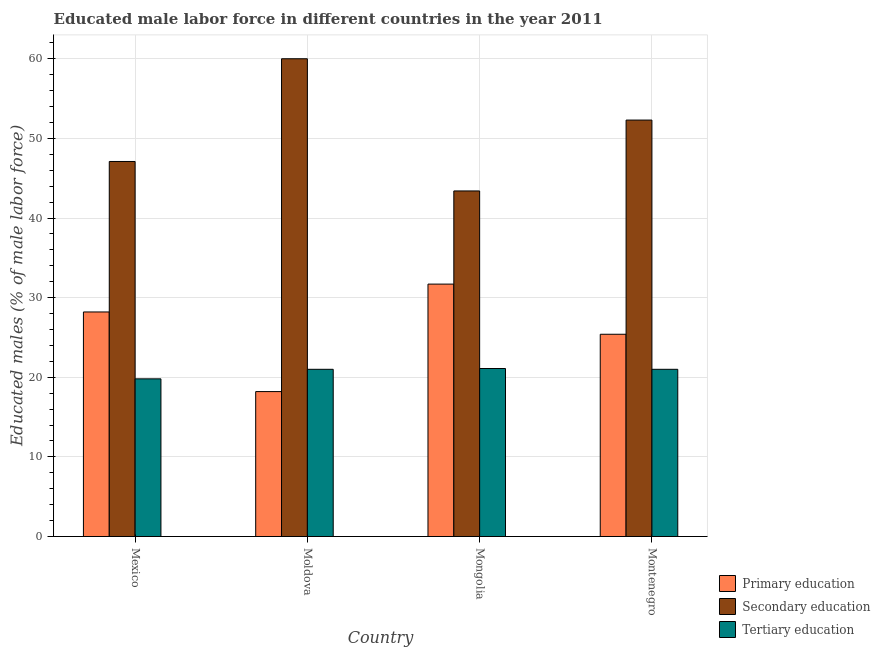How many different coloured bars are there?
Provide a succinct answer. 3. What is the label of the 4th group of bars from the left?
Keep it short and to the point. Montenegro. What is the percentage of male labor force who received primary education in Montenegro?
Keep it short and to the point. 25.4. Across all countries, what is the maximum percentage of male labor force who received secondary education?
Offer a very short reply. 60. Across all countries, what is the minimum percentage of male labor force who received tertiary education?
Keep it short and to the point. 19.8. In which country was the percentage of male labor force who received tertiary education maximum?
Provide a succinct answer. Mongolia. In which country was the percentage of male labor force who received primary education minimum?
Your answer should be very brief. Moldova. What is the total percentage of male labor force who received tertiary education in the graph?
Provide a short and direct response. 82.9. What is the difference between the percentage of male labor force who received tertiary education in Mexico and that in Mongolia?
Make the answer very short. -1.3. What is the difference between the percentage of male labor force who received tertiary education in Mexico and the percentage of male labor force who received secondary education in Mongolia?
Ensure brevity in your answer.  -23.6. What is the average percentage of male labor force who received primary education per country?
Provide a succinct answer. 25.88. What is the difference between the percentage of male labor force who received primary education and percentage of male labor force who received tertiary education in Montenegro?
Ensure brevity in your answer.  4.4. In how many countries, is the percentage of male labor force who received tertiary education greater than 52 %?
Your answer should be compact. 0. What is the ratio of the percentage of male labor force who received secondary education in Mexico to that in Mongolia?
Provide a succinct answer. 1.09. Is the percentage of male labor force who received secondary education in Mongolia less than that in Montenegro?
Provide a succinct answer. Yes. What is the difference between the highest and the second highest percentage of male labor force who received tertiary education?
Provide a succinct answer. 0.1. What is the difference between the highest and the lowest percentage of male labor force who received secondary education?
Provide a short and direct response. 16.6. In how many countries, is the percentage of male labor force who received secondary education greater than the average percentage of male labor force who received secondary education taken over all countries?
Offer a terse response. 2. Is the sum of the percentage of male labor force who received tertiary education in Mexico and Moldova greater than the maximum percentage of male labor force who received secondary education across all countries?
Provide a short and direct response. No. What does the 1st bar from the left in Mongolia represents?
Make the answer very short. Primary education. Are all the bars in the graph horizontal?
Provide a short and direct response. No. How many countries are there in the graph?
Offer a terse response. 4. What is the difference between two consecutive major ticks on the Y-axis?
Your response must be concise. 10. Are the values on the major ticks of Y-axis written in scientific E-notation?
Keep it short and to the point. No. Does the graph contain grids?
Offer a very short reply. Yes. What is the title of the graph?
Provide a short and direct response. Educated male labor force in different countries in the year 2011. Does "Wage workers" appear as one of the legend labels in the graph?
Offer a very short reply. No. What is the label or title of the Y-axis?
Make the answer very short. Educated males (% of male labor force). What is the Educated males (% of male labor force) in Primary education in Mexico?
Make the answer very short. 28.2. What is the Educated males (% of male labor force) in Secondary education in Mexico?
Your answer should be very brief. 47.1. What is the Educated males (% of male labor force) of Tertiary education in Mexico?
Provide a short and direct response. 19.8. What is the Educated males (% of male labor force) in Primary education in Moldova?
Make the answer very short. 18.2. What is the Educated males (% of male labor force) in Secondary education in Moldova?
Offer a terse response. 60. What is the Educated males (% of male labor force) of Tertiary education in Moldova?
Offer a very short reply. 21. What is the Educated males (% of male labor force) of Primary education in Mongolia?
Offer a very short reply. 31.7. What is the Educated males (% of male labor force) of Secondary education in Mongolia?
Your response must be concise. 43.4. What is the Educated males (% of male labor force) in Tertiary education in Mongolia?
Your answer should be very brief. 21.1. What is the Educated males (% of male labor force) in Primary education in Montenegro?
Your response must be concise. 25.4. What is the Educated males (% of male labor force) in Secondary education in Montenegro?
Make the answer very short. 52.3. What is the Educated males (% of male labor force) in Tertiary education in Montenegro?
Ensure brevity in your answer.  21. Across all countries, what is the maximum Educated males (% of male labor force) of Primary education?
Your answer should be compact. 31.7. Across all countries, what is the maximum Educated males (% of male labor force) in Secondary education?
Offer a terse response. 60. Across all countries, what is the maximum Educated males (% of male labor force) in Tertiary education?
Offer a very short reply. 21.1. Across all countries, what is the minimum Educated males (% of male labor force) in Primary education?
Your answer should be compact. 18.2. Across all countries, what is the minimum Educated males (% of male labor force) of Secondary education?
Ensure brevity in your answer.  43.4. Across all countries, what is the minimum Educated males (% of male labor force) in Tertiary education?
Give a very brief answer. 19.8. What is the total Educated males (% of male labor force) in Primary education in the graph?
Give a very brief answer. 103.5. What is the total Educated males (% of male labor force) in Secondary education in the graph?
Give a very brief answer. 202.8. What is the total Educated males (% of male labor force) of Tertiary education in the graph?
Give a very brief answer. 82.9. What is the difference between the Educated males (% of male labor force) in Secondary education in Mexico and that in Moldova?
Your response must be concise. -12.9. What is the difference between the Educated males (% of male labor force) in Primary education in Mexico and that in Montenegro?
Make the answer very short. 2.8. What is the difference between the Educated males (% of male labor force) of Primary education in Moldova and that in Mongolia?
Your response must be concise. -13.5. What is the difference between the Educated males (% of male labor force) in Primary education in Mongolia and that in Montenegro?
Your response must be concise. 6.3. What is the difference between the Educated males (% of male labor force) of Tertiary education in Mongolia and that in Montenegro?
Your answer should be compact. 0.1. What is the difference between the Educated males (% of male labor force) in Primary education in Mexico and the Educated males (% of male labor force) in Secondary education in Moldova?
Offer a terse response. -31.8. What is the difference between the Educated males (% of male labor force) in Primary education in Mexico and the Educated males (% of male labor force) in Tertiary education in Moldova?
Your answer should be very brief. 7.2. What is the difference between the Educated males (% of male labor force) in Secondary education in Mexico and the Educated males (% of male labor force) in Tertiary education in Moldova?
Offer a very short reply. 26.1. What is the difference between the Educated males (% of male labor force) in Primary education in Mexico and the Educated males (% of male labor force) in Secondary education in Mongolia?
Ensure brevity in your answer.  -15.2. What is the difference between the Educated males (% of male labor force) of Primary education in Mexico and the Educated males (% of male labor force) of Tertiary education in Mongolia?
Give a very brief answer. 7.1. What is the difference between the Educated males (% of male labor force) in Primary education in Mexico and the Educated males (% of male labor force) in Secondary education in Montenegro?
Keep it short and to the point. -24.1. What is the difference between the Educated males (% of male labor force) in Secondary education in Mexico and the Educated males (% of male labor force) in Tertiary education in Montenegro?
Offer a very short reply. 26.1. What is the difference between the Educated males (% of male labor force) in Primary education in Moldova and the Educated males (% of male labor force) in Secondary education in Mongolia?
Ensure brevity in your answer.  -25.2. What is the difference between the Educated males (% of male labor force) in Secondary education in Moldova and the Educated males (% of male labor force) in Tertiary education in Mongolia?
Ensure brevity in your answer.  38.9. What is the difference between the Educated males (% of male labor force) in Primary education in Moldova and the Educated males (% of male labor force) in Secondary education in Montenegro?
Ensure brevity in your answer.  -34.1. What is the difference between the Educated males (% of male labor force) in Secondary education in Moldova and the Educated males (% of male labor force) in Tertiary education in Montenegro?
Provide a succinct answer. 39. What is the difference between the Educated males (% of male labor force) in Primary education in Mongolia and the Educated males (% of male labor force) in Secondary education in Montenegro?
Your response must be concise. -20.6. What is the difference between the Educated males (% of male labor force) in Primary education in Mongolia and the Educated males (% of male labor force) in Tertiary education in Montenegro?
Provide a short and direct response. 10.7. What is the difference between the Educated males (% of male labor force) in Secondary education in Mongolia and the Educated males (% of male labor force) in Tertiary education in Montenegro?
Your answer should be compact. 22.4. What is the average Educated males (% of male labor force) in Primary education per country?
Your answer should be very brief. 25.88. What is the average Educated males (% of male labor force) of Secondary education per country?
Your answer should be compact. 50.7. What is the average Educated males (% of male labor force) in Tertiary education per country?
Offer a very short reply. 20.73. What is the difference between the Educated males (% of male labor force) in Primary education and Educated males (% of male labor force) in Secondary education in Mexico?
Make the answer very short. -18.9. What is the difference between the Educated males (% of male labor force) of Primary education and Educated males (% of male labor force) of Tertiary education in Mexico?
Make the answer very short. 8.4. What is the difference between the Educated males (% of male labor force) of Secondary education and Educated males (% of male labor force) of Tertiary education in Mexico?
Your answer should be very brief. 27.3. What is the difference between the Educated males (% of male labor force) in Primary education and Educated males (% of male labor force) in Secondary education in Moldova?
Your answer should be very brief. -41.8. What is the difference between the Educated males (% of male labor force) of Primary education and Educated males (% of male labor force) of Tertiary education in Mongolia?
Your response must be concise. 10.6. What is the difference between the Educated males (% of male labor force) in Secondary education and Educated males (% of male labor force) in Tertiary education in Mongolia?
Ensure brevity in your answer.  22.3. What is the difference between the Educated males (% of male labor force) of Primary education and Educated males (% of male labor force) of Secondary education in Montenegro?
Keep it short and to the point. -26.9. What is the difference between the Educated males (% of male labor force) in Primary education and Educated males (% of male labor force) in Tertiary education in Montenegro?
Ensure brevity in your answer.  4.4. What is the difference between the Educated males (% of male labor force) in Secondary education and Educated males (% of male labor force) in Tertiary education in Montenegro?
Your answer should be very brief. 31.3. What is the ratio of the Educated males (% of male labor force) of Primary education in Mexico to that in Moldova?
Your answer should be very brief. 1.55. What is the ratio of the Educated males (% of male labor force) of Secondary education in Mexico to that in Moldova?
Your answer should be very brief. 0.79. What is the ratio of the Educated males (% of male labor force) in Tertiary education in Mexico to that in Moldova?
Your answer should be compact. 0.94. What is the ratio of the Educated males (% of male labor force) in Primary education in Mexico to that in Mongolia?
Your answer should be very brief. 0.89. What is the ratio of the Educated males (% of male labor force) in Secondary education in Mexico to that in Mongolia?
Your answer should be compact. 1.09. What is the ratio of the Educated males (% of male labor force) of Tertiary education in Mexico to that in Mongolia?
Give a very brief answer. 0.94. What is the ratio of the Educated males (% of male labor force) of Primary education in Mexico to that in Montenegro?
Provide a succinct answer. 1.11. What is the ratio of the Educated males (% of male labor force) in Secondary education in Mexico to that in Montenegro?
Ensure brevity in your answer.  0.9. What is the ratio of the Educated males (% of male labor force) in Tertiary education in Mexico to that in Montenegro?
Offer a terse response. 0.94. What is the ratio of the Educated males (% of male labor force) of Primary education in Moldova to that in Mongolia?
Your response must be concise. 0.57. What is the ratio of the Educated males (% of male labor force) of Secondary education in Moldova to that in Mongolia?
Make the answer very short. 1.38. What is the ratio of the Educated males (% of male labor force) of Tertiary education in Moldova to that in Mongolia?
Give a very brief answer. 1. What is the ratio of the Educated males (% of male labor force) of Primary education in Moldova to that in Montenegro?
Provide a succinct answer. 0.72. What is the ratio of the Educated males (% of male labor force) of Secondary education in Moldova to that in Montenegro?
Your answer should be very brief. 1.15. What is the ratio of the Educated males (% of male labor force) in Tertiary education in Moldova to that in Montenegro?
Provide a short and direct response. 1. What is the ratio of the Educated males (% of male labor force) of Primary education in Mongolia to that in Montenegro?
Ensure brevity in your answer.  1.25. What is the ratio of the Educated males (% of male labor force) in Secondary education in Mongolia to that in Montenegro?
Give a very brief answer. 0.83. What is the difference between the highest and the second highest Educated males (% of male labor force) in Primary education?
Offer a terse response. 3.5. What is the difference between the highest and the lowest Educated males (% of male labor force) in Secondary education?
Provide a short and direct response. 16.6. What is the difference between the highest and the lowest Educated males (% of male labor force) of Tertiary education?
Provide a short and direct response. 1.3. 